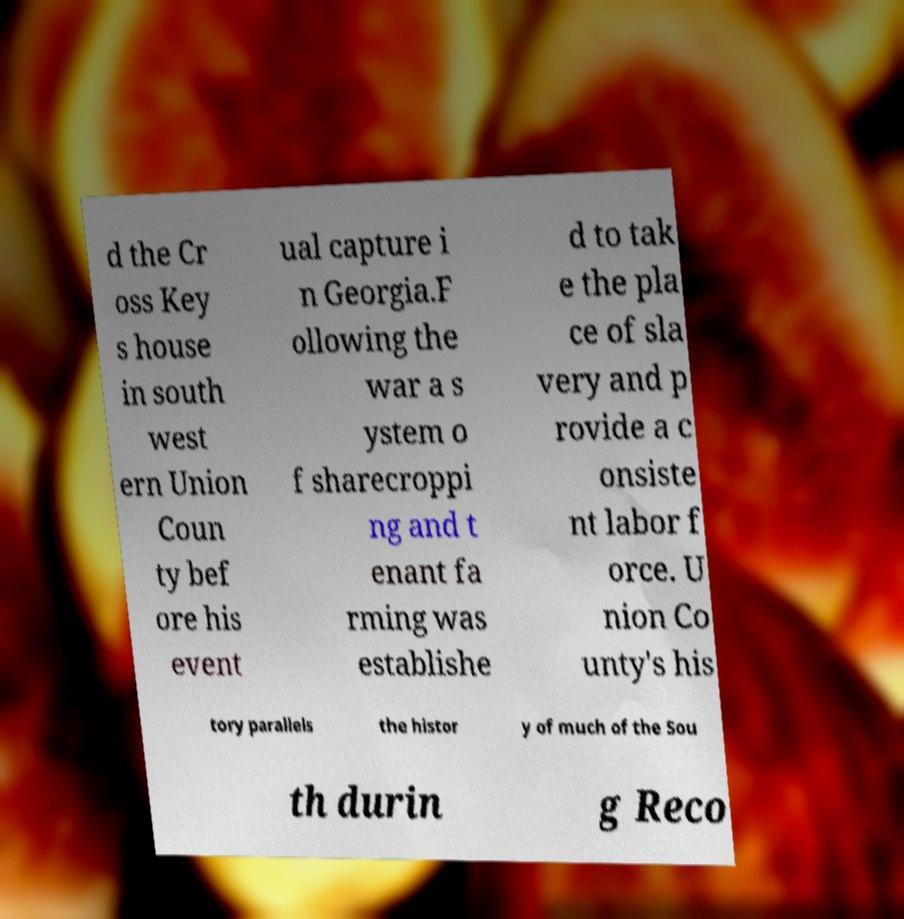For documentation purposes, I need the text within this image transcribed. Could you provide that? d the Cr oss Key s house in south west ern Union Coun ty bef ore his event ual capture i n Georgia.F ollowing the war a s ystem o f sharecroppi ng and t enant fa rming was establishe d to tak e the pla ce of sla very and p rovide a c onsiste nt labor f orce. U nion Co unty's his tory parallels the histor y of much of the Sou th durin g Reco 